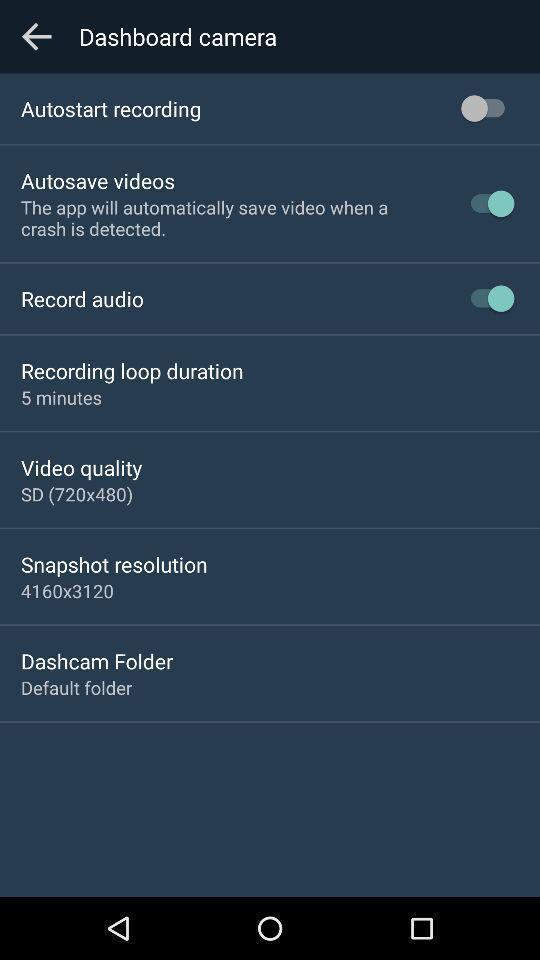Describe the visual elements of this screenshot. Screen displaying the list of options with toggle icons. 